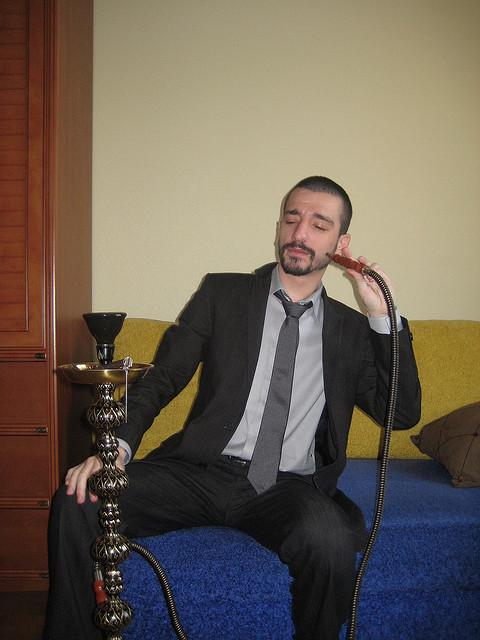What comes through the pipe held here? Please explain your reasoning. smoke. The pipe is attached to a hookah. it does not emit oil, cookies, or milk. 